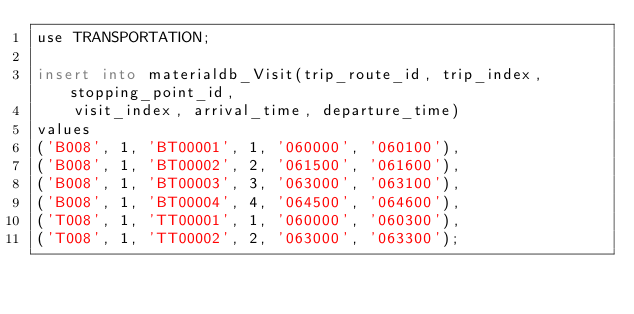Convert code to text. <code><loc_0><loc_0><loc_500><loc_500><_SQL_>use TRANSPORTATION;

insert into materialdb_Visit(trip_route_id, trip_index, stopping_point_id, 
	visit_index, arrival_time, departure_time)
values
('B008', 1, 'BT00001', 1, '060000', '060100'),
('B008', 1, 'BT00002', 2, '061500', '061600'),
('B008', 1, 'BT00003', 3, '063000', '063100'),
('B008', 1, 'BT00004', 4, '064500', '064600'),
('T008', 1, 'TT00001', 1, '060000', '060300'),
('T008', 1, 'TT00002', 2, '063000', '063300');</code> 